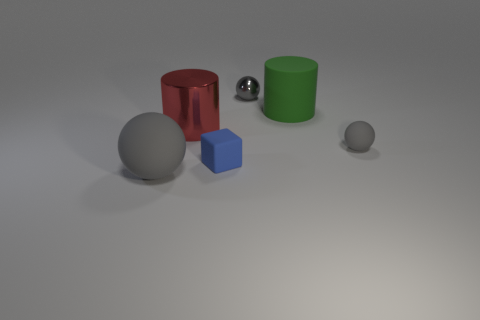How big is the thing that is both behind the blue rubber cube and left of the small gray metal ball?
Make the answer very short. Large. Are there more red things that are left of the green matte cylinder than small gray metal balls in front of the blue matte cube?
Make the answer very short. Yes. Does the green matte object have the same shape as the gray thing left of the red cylinder?
Your answer should be compact. No. What number of other objects are there of the same shape as the tiny gray metal thing?
Provide a short and direct response. 2. What is the color of the matte object that is both right of the blue rubber block and in front of the matte cylinder?
Make the answer very short. Gray. The large metallic thing has what color?
Provide a short and direct response. Red. Is the material of the small blue block the same as the gray thing behind the green matte cylinder?
Give a very brief answer. No. The blue thing that is the same material as the big green thing is what shape?
Offer a very short reply. Cube. There is a cylinder that is the same size as the red metal thing; what color is it?
Provide a short and direct response. Green. There is a gray thing to the right of the green cylinder; is its size the same as the block?
Provide a succinct answer. Yes. 